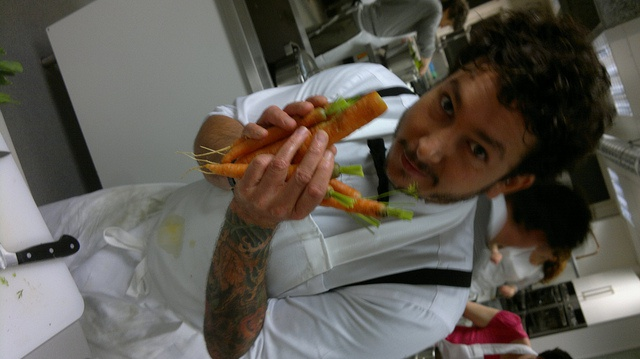Describe the objects in this image and their specific colors. I can see people in black, gray, maroon, and darkgray tones, people in black, maroon, and gray tones, carrot in black, maroon, brown, and olive tones, people in black, maroon, gray, and darkgray tones, and people in black and gray tones in this image. 